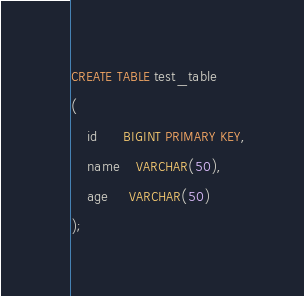Convert code to text. <code><loc_0><loc_0><loc_500><loc_500><_SQL_>CREATE TABLE test_table
(
    id      BIGINT PRIMARY KEY,
    name    VARCHAR(50),
    age     VARCHAR(50)
);
</code> 